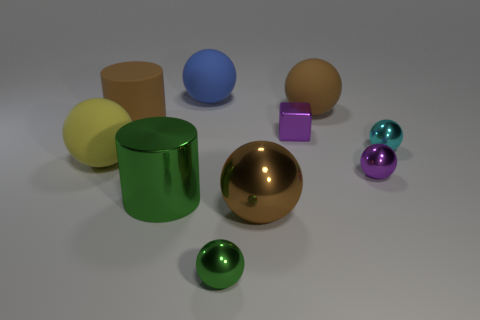Could you infer the size relationship between these objects? While there is no explicit reference for scale, the relative sizes of the objects to one another imply that they vary in size. For instance, the blue sphere looks to be of medium size compared to the smaller purple cube and the larger yellow cylindrical object. Without a common item for scale comparison, an exact size measurement is not possible, but we can infer a size hierarchy among the objects. 